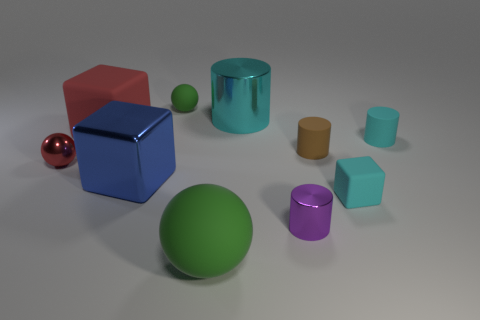Is the shape of the brown object the same as the red matte object?
Ensure brevity in your answer.  No. What is the material of the blue cube that is the same size as the cyan metal cylinder?
Your answer should be very brief. Metal. Is the shape of the brown object the same as the cyan matte object that is in front of the small red thing?
Keep it short and to the point. No. What color is the other rubber thing that is the same shape as the brown rubber object?
Offer a very short reply. Cyan. What number of balls are small green matte things or small red metallic objects?
Make the answer very short. 2. What is the shape of the red metal thing?
Ensure brevity in your answer.  Sphere. Are there any tiny brown things in front of the cyan metal thing?
Offer a very short reply. Yes. Does the brown thing have the same material as the cyan thing that is left of the tiny cyan block?
Keep it short and to the point. No. Do the object behind the cyan metallic cylinder and the big green object have the same shape?
Your answer should be compact. Yes. How many small cyan cylinders are made of the same material as the purple thing?
Provide a short and direct response. 0. 